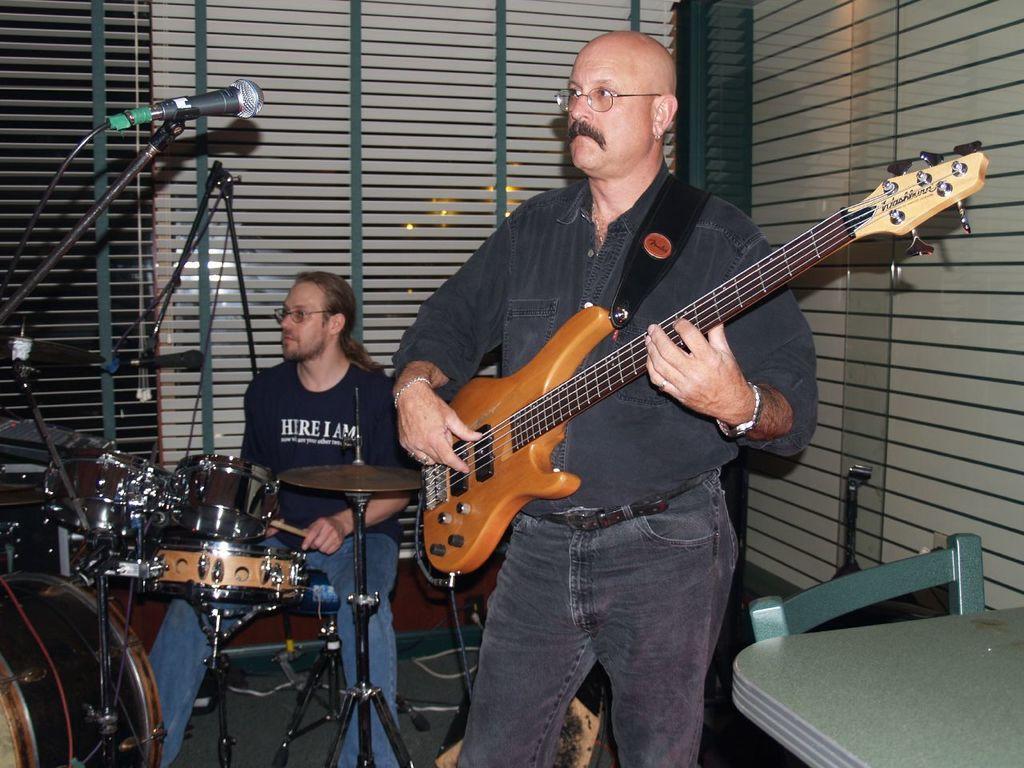How would you summarize this image in a sentence or two? Here we can see one man wearing spectacles standing in front of a mike and playing guitar. We can see one man with a short hair, wearing spectacles sitting and playing drums. This is a table. 